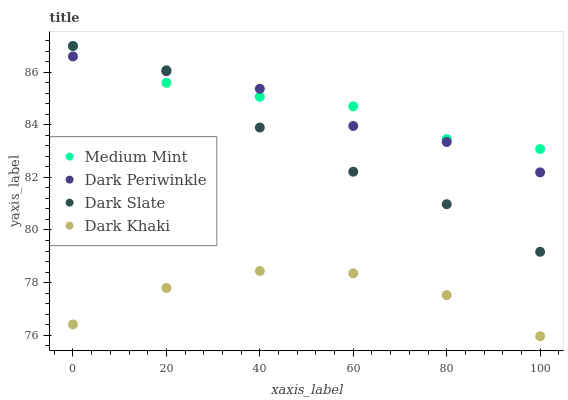Does Dark Khaki have the minimum area under the curve?
Answer yes or no. Yes. Does Medium Mint have the maximum area under the curve?
Answer yes or no. Yes. Does Dark Slate have the minimum area under the curve?
Answer yes or no. No. Does Dark Slate have the maximum area under the curve?
Answer yes or no. No. Is Dark Periwinkle the smoothest?
Answer yes or no. Yes. Is Dark Khaki the roughest?
Answer yes or no. Yes. Is Dark Slate the smoothest?
Answer yes or no. No. Is Dark Slate the roughest?
Answer yes or no. No. Does Dark Khaki have the lowest value?
Answer yes or no. Yes. Does Dark Slate have the lowest value?
Answer yes or no. No. Does Dark Slate have the highest value?
Answer yes or no. Yes. Does Dark Khaki have the highest value?
Answer yes or no. No. Is Dark Khaki less than Medium Mint?
Answer yes or no. Yes. Is Dark Slate greater than Dark Khaki?
Answer yes or no. Yes. Does Dark Periwinkle intersect Dark Slate?
Answer yes or no. Yes. Is Dark Periwinkle less than Dark Slate?
Answer yes or no. No. Is Dark Periwinkle greater than Dark Slate?
Answer yes or no. No. Does Dark Khaki intersect Medium Mint?
Answer yes or no. No. 